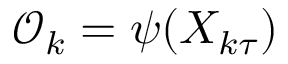Convert formula to latex. <formula><loc_0><loc_0><loc_500><loc_500>\mathcal { O } _ { k } = \psi ( X _ { k \tau } )</formula> 